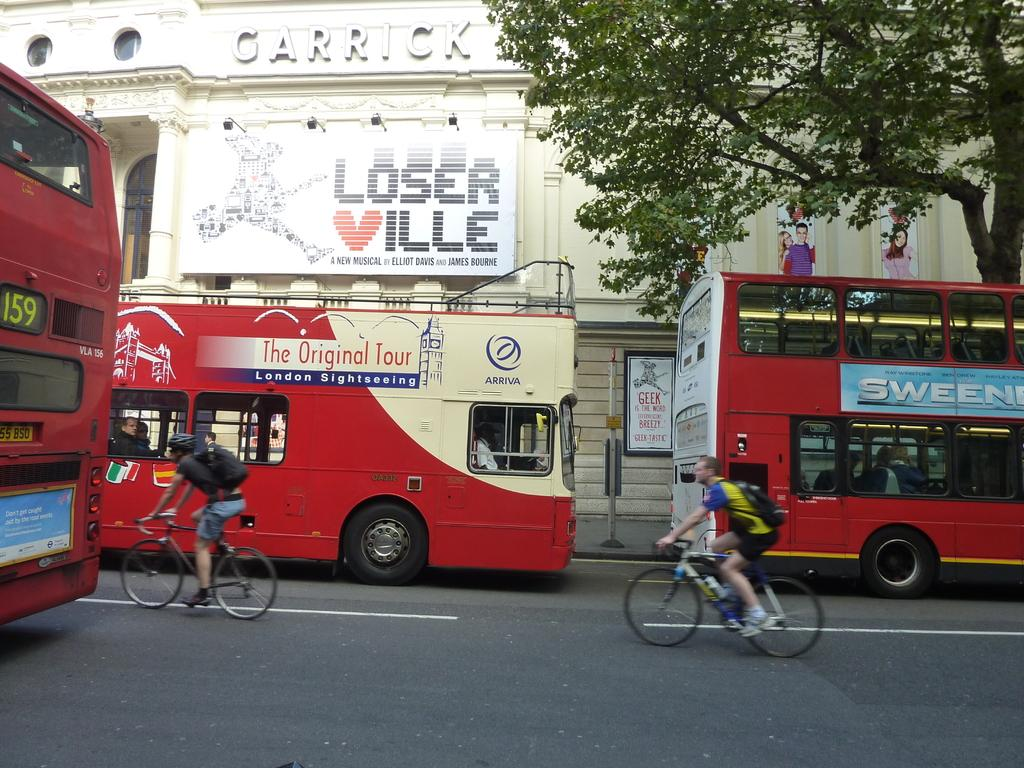What type of vehicles can be seen in the image? There are buses in the image. What are people doing on the road in the image? People are riding bicycles on the road. What can be seen in the background of the image? There is a house in the background of the image. What is on the house in the image? The house has posters on it. What type of vegetation is on the right side of the image? There is a tree on the right side of the image. Where is the throne located in the image? There is no throne present in the image. What is the profit margin of the buses in the image? There is no information about profit margins in the image; it only shows buses and people riding bicycles. 